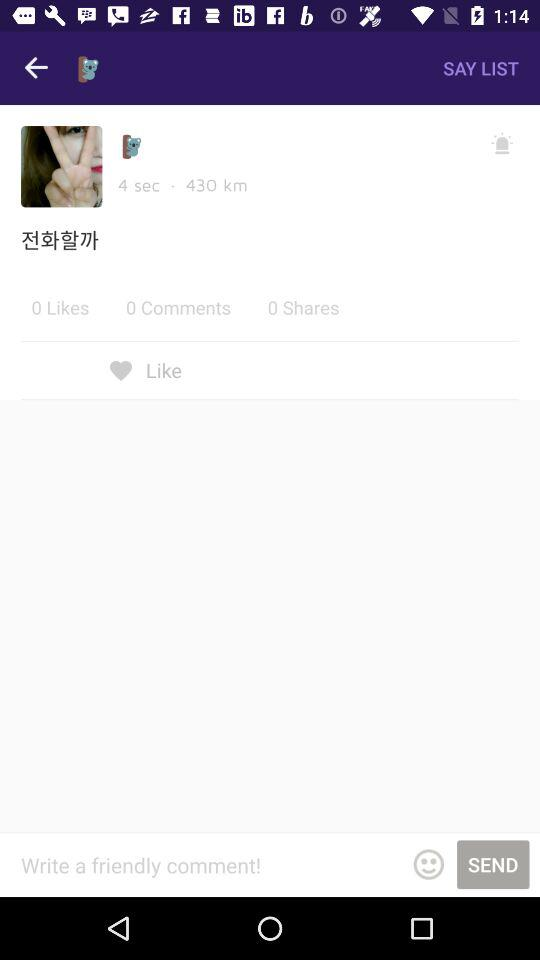How much is the distance mentioned? The distance mentioned is 430 km. 